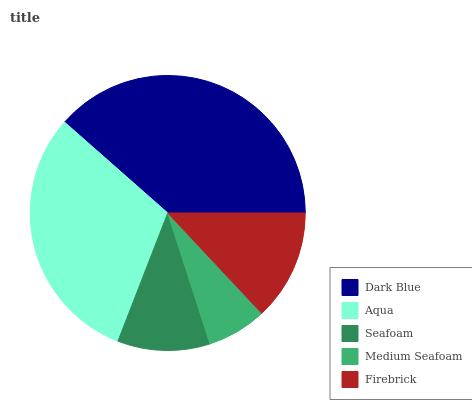Is Medium Seafoam the minimum?
Answer yes or no. Yes. Is Dark Blue the maximum?
Answer yes or no. Yes. Is Aqua the minimum?
Answer yes or no. No. Is Aqua the maximum?
Answer yes or no. No. Is Dark Blue greater than Aqua?
Answer yes or no. Yes. Is Aqua less than Dark Blue?
Answer yes or no. Yes. Is Aqua greater than Dark Blue?
Answer yes or no. No. Is Dark Blue less than Aqua?
Answer yes or no. No. Is Firebrick the high median?
Answer yes or no. Yes. Is Firebrick the low median?
Answer yes or no. Yes. Is Seafoam the high median?
Answer yes or no. No. Is Aqua the low median?
Answer yes or no. No. 